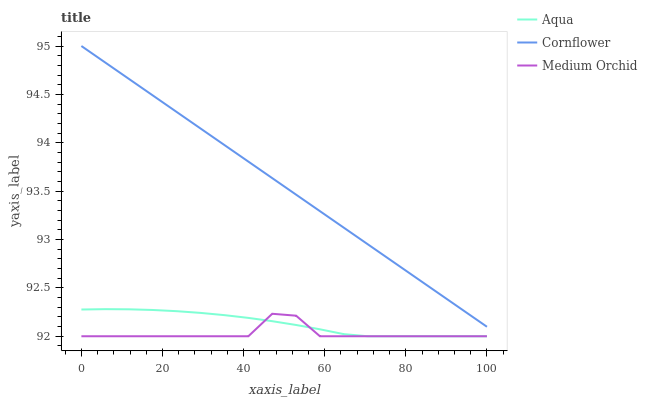Does Medium Orchid have the minimum area under the curve?
Answer yes or no. Yes. Does Cornflower have the maximum area under the curve?
Answer yes or no. Yes. Does Aqua have the minimum area under the curve?
Answer yes or no. No. Does Aqua have the maximum area under the curve?
Answer yes or no. No. Is Cornflower the smoothest?
Answer yes or no. Yes. Is Medium Orchid the roughest?
Answer yes or no. Yes. Is Aqua the smoothest?
Answer yes or no. No. Is Aqua the roughest?
Answer yes or no. No. Does Medium Orchid have the lowest value?
Answer yes or no. Yes. Does Cornflower have the highest value?
Answer yes or no. Yes. Does Aqua have the highest value?
Answer yes or no. No. Is Medium Orchid less than Cornflower?
Answer yes or no. Yes. Is Cornflower greater than Medium Orchid?
Answer yes or no. Yes. Does Medium Orchid intersect Aqua?
Answer yes or no. Yes. Is Medium Orchid less than Aqua?
Answer yes or no. No. Is Medium Orchid greater than Aqua?
Answer yes or no. No. Does Medium Orchid intersect Cornflower?
Answer yes or no. No. 